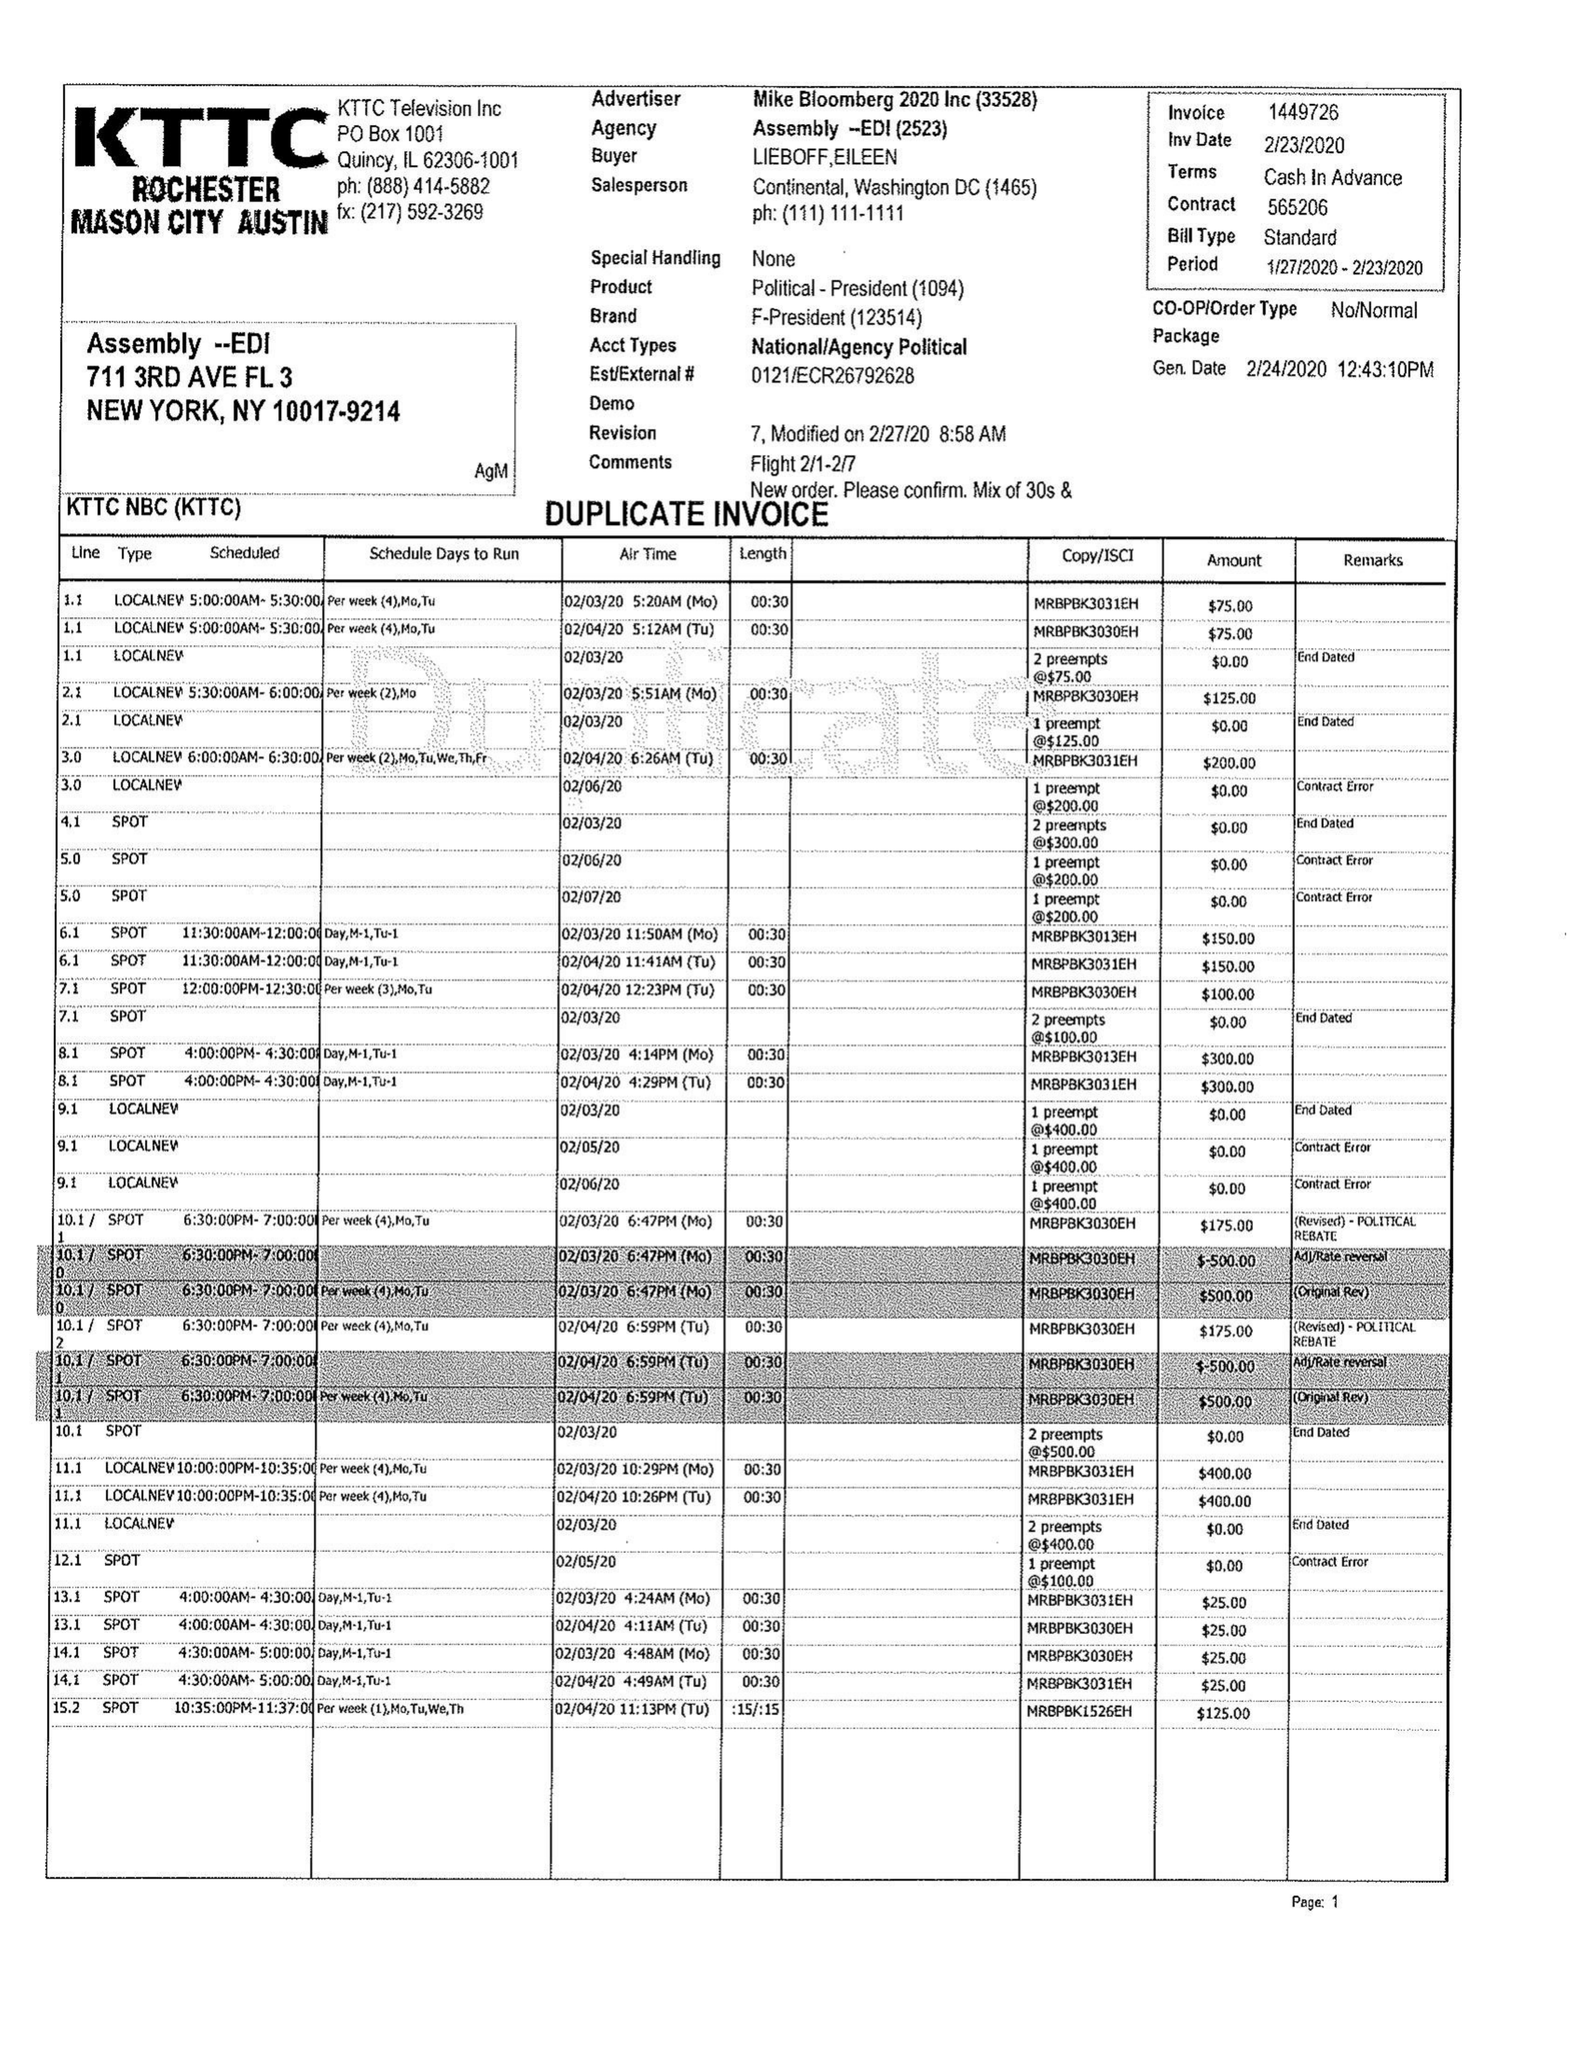What is the value for the contract_num?
Answer the question using a single word or phrase. 1449726 